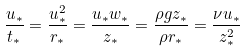Convert formula to latex. <formula><loc_0><loc_0><loc_500><loc_500>\frac { u _ { * } } { t _ { * } } = \frac { u _ { * } ^ { 2 } } { r _ { * } } = \frac { u _ { * } w _ { * } } { z _ { * } } = \frac { \rho g z _ { * } } { \rho r _ { * } } = \frac { \nu u _ { * } } { z _ { * } ^ { 2 } }</formula> 